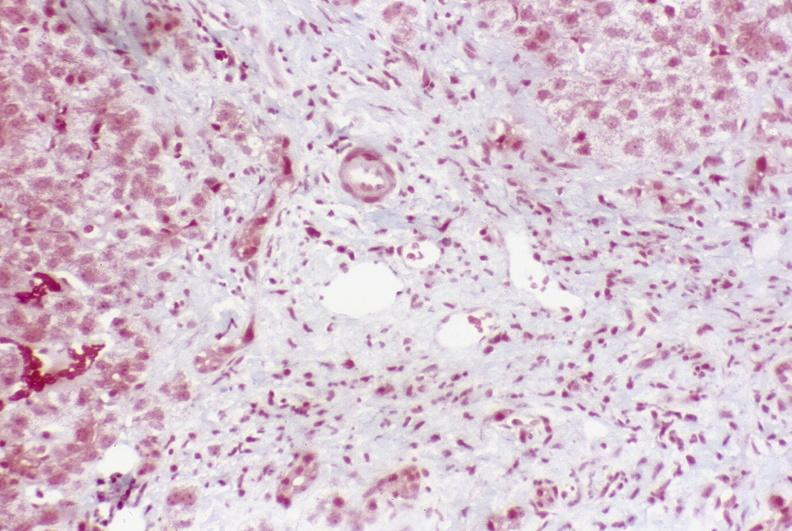s hepatobiliary present?
Answer the question using a single word or phrase. Yes 